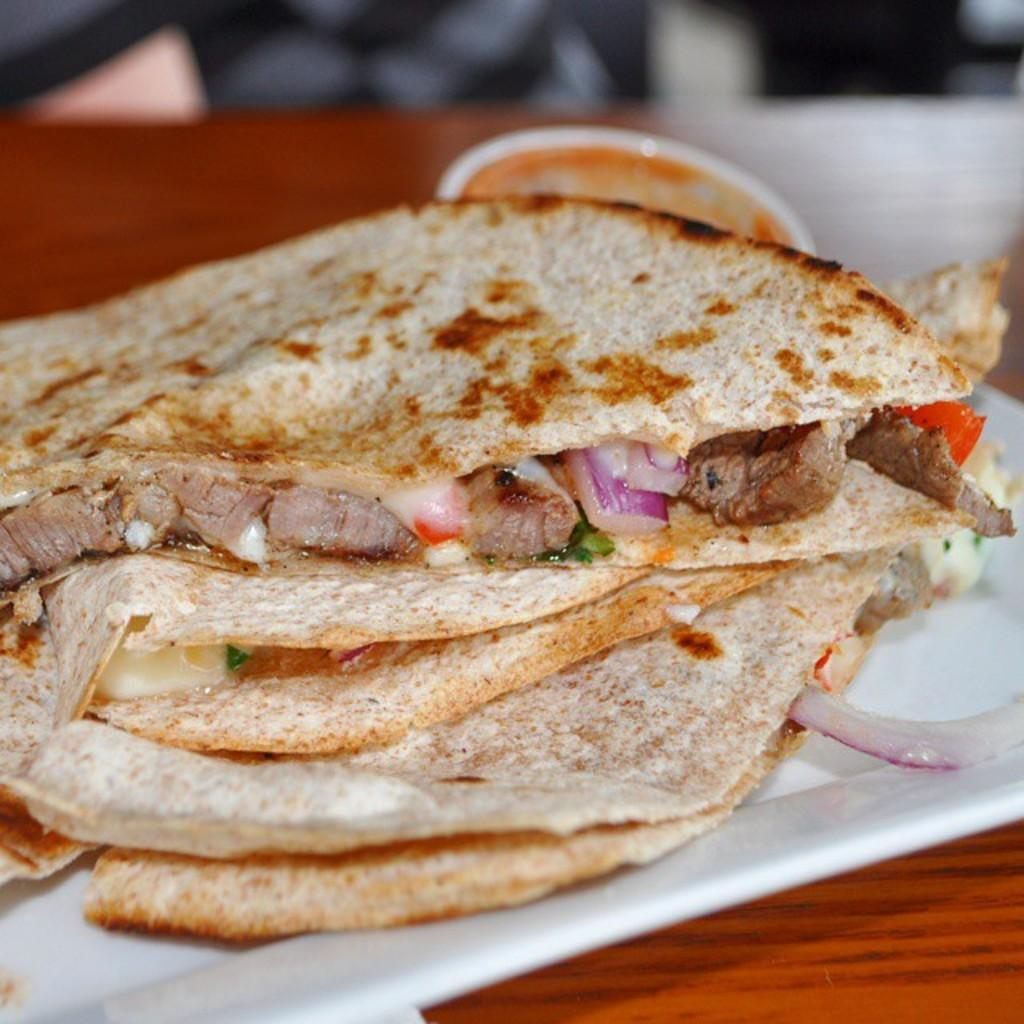What is on the plate in the image? There is food on the plate in the image. Can you describe the background of the image? The background of the image is blurry. What thought is the food having in the image? The food does not have thoughts, as it is an inanimate object. 